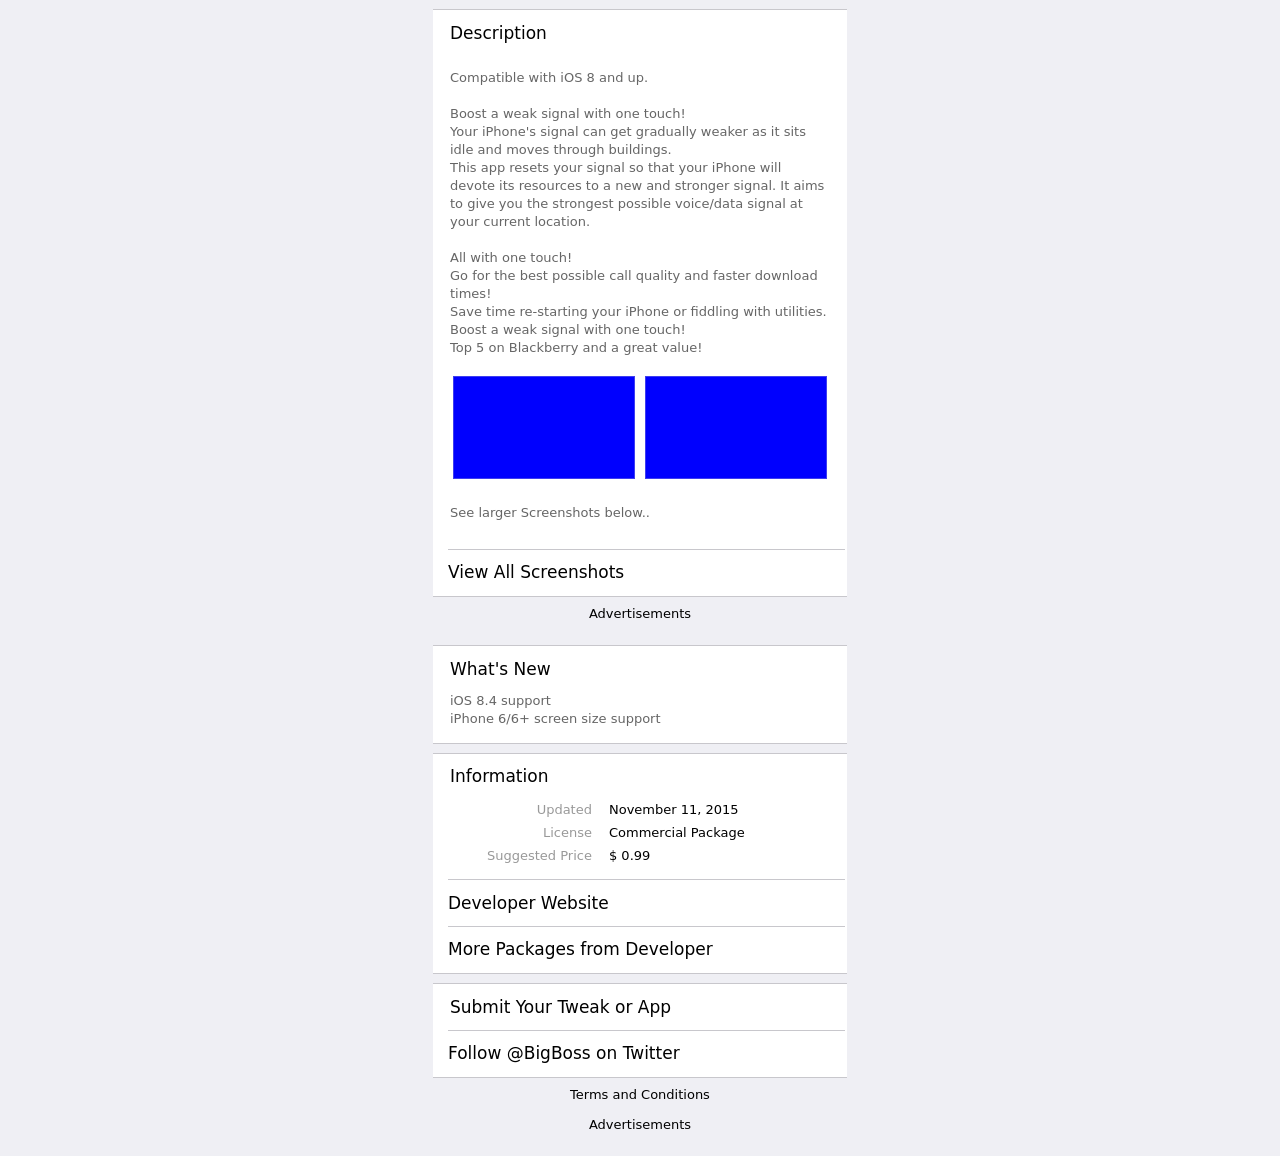What are the main features highlighted in this website template? The main features highlighted in the website template shown in the image include compatibility with iOS 8 and up, a one-touch signal boosting capability, easy access to larger screenshots, iOS and iPhone screen size support update details, and commercial package information, including price and update history.  What improvements does this update bring to the website? The update brings iOS 8.4 support and enhanced screen size support for iPhone 6 and iPhone 6+. This indicates that the website is now optimized to work seamlessly with newer versions of iOS and to look good on the latest iPhone models, ensuring users have a better experience with the signal boosting functionality and the overall website layout. 